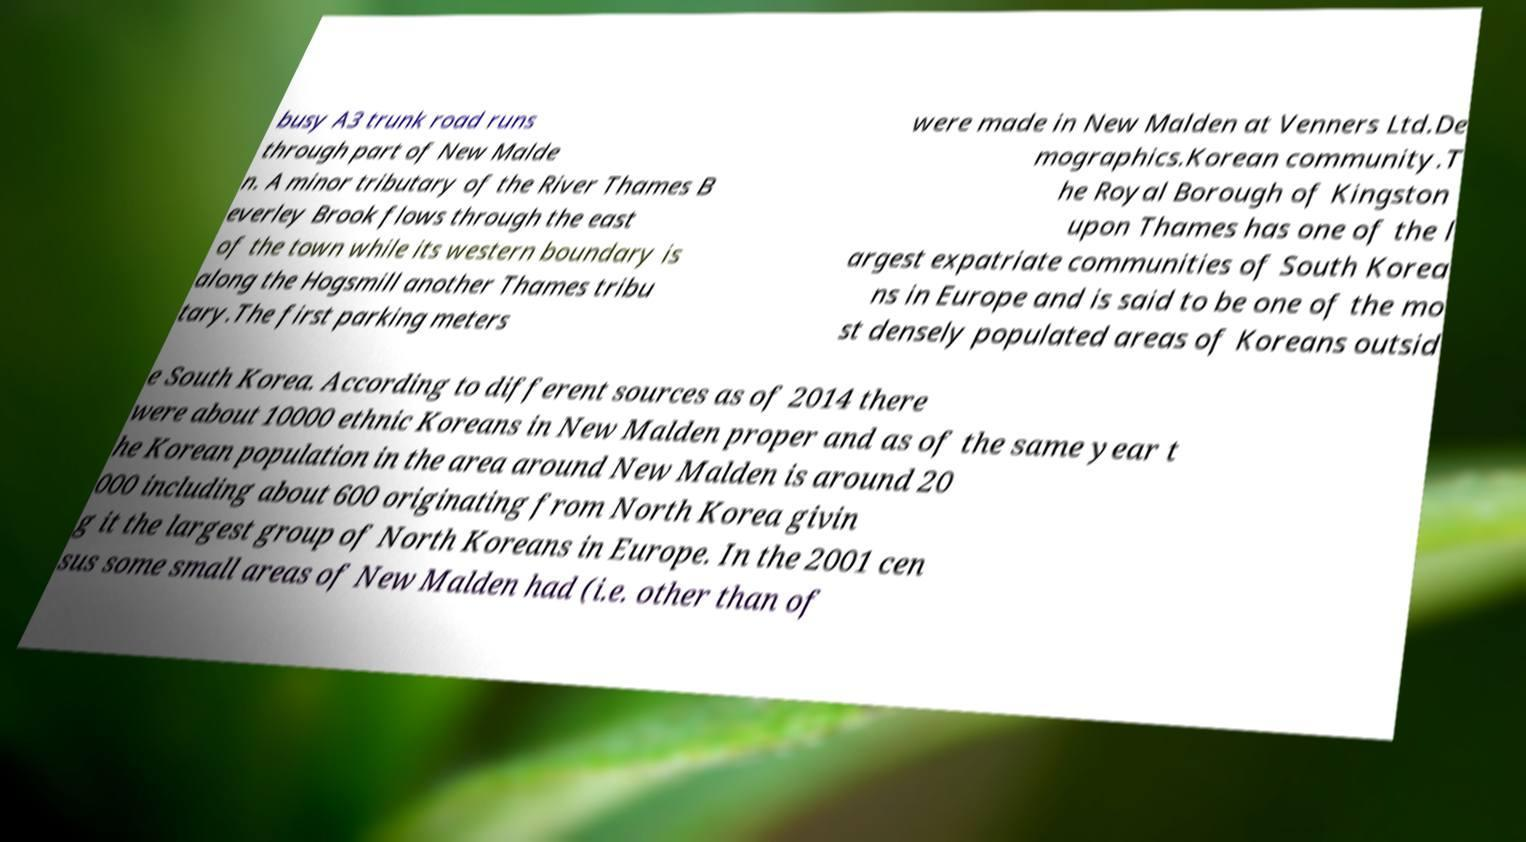Please read and relay the text visible in this image. What does it say? busy A3 trunk road runs through part of New Malde n. A minor tributary of the River Thames B everley Brook flows through the east of the town while its western boundary is along the Hogsmill another Thames tribu tary.The first parking meters were made in New Malden at Venners Ltd.De mographics.Korean community.T he Royal Borough of Kingston upon Thames has one of the l argest expatriate communities of South Korea ns in Europe and is said to be one of the mo st densely populated areas of Koreans outsid e South Korea. According to different sources as of 2014 there were about 10000 ethnic Koreans in New Malden proper and as of the same year t he Korean population in the area around New Malden is around 20 000 including about 600 originating from North Korea givin g it the largest group of North Koreans in Europe. In the 2001 cen sus some small areas of New Malden had (i.e. other than of 